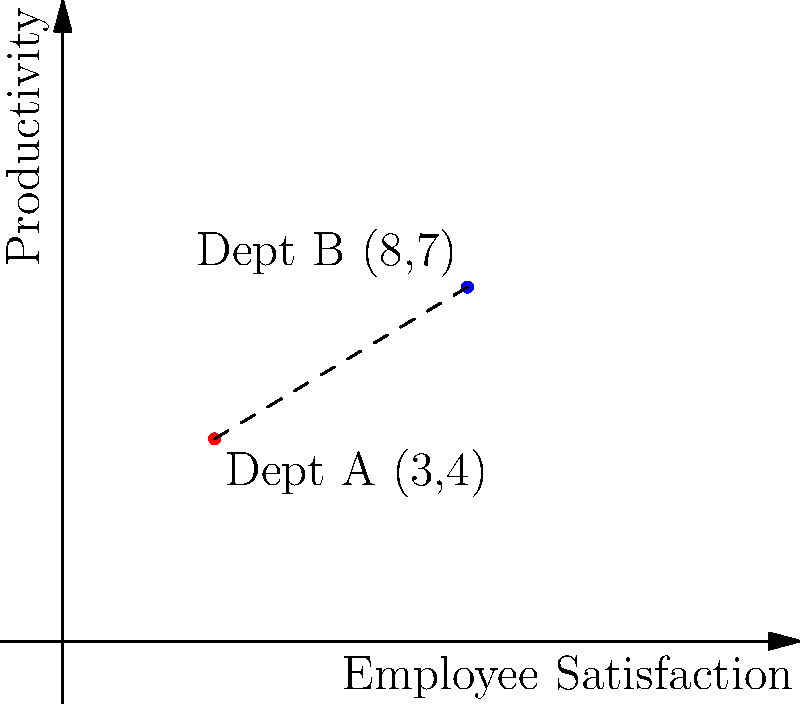As an industrial psychologist, you're analyzing the performance of two departments in terms of employee satisfaction and productivity. Department A has coordinates (3,4) and Department B has coordinates (8,7) on a graph where the x-axis represents employee satisfaction and the y-axis represents productivity. Calculate the Euclidean distance between these two departments' performance metrics to quantify their overall difference in performance. Round your answer to two decimal places. To solve this problem, we'll use the distance formula derived from the Pythagorean theorem:

1) The distance formula is:
   $$d = \sqrt{(x_2 - x_1)^2 + (y_2 - y_1)^2}$$

2) We have:
   Department A: $(x_1, y_1) = (3, 4)$
   Department B: $(x_2, y_2) = (8, 7)$

3) Let's substitute these values into the formula:
   $$d = \sqrt{(8 - 3)^2 + (7 - 4)^2}$$

4) Simplify inside the parentheses:
   $$d = \sqrt{5^2 + 3^2}$$

5) Calculate the squares:
   $$d = \sqrt{25 + 9}$$

6) Add inside the square root:
   $$d = \sqrt{34}$$

7) Calculate the square root:
   $$d \approx 5.8309$$

8) Rounding to two decimal places:
   $$d \approx 5.83$$

This distance represents the overall difference in performance between the two departments, considering both employee satisfaction and productivity.
Answer: 5.83 